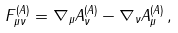<formula> <loc_0><loc_0><loc_500><loc_500>F _ { \mu \nu } ^ { ( A ) } = \nabla _ { \mu } A _ { \nu } ^ { ( A ) } - \nabla _ { \nu } A _ { \mu } ^ { ( A ) } \, ,</formula> 